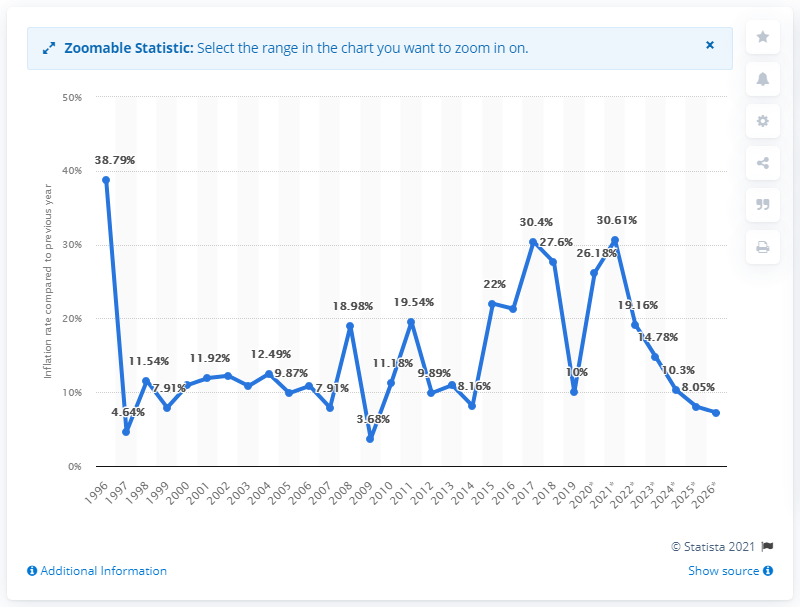Mention a couple of crucial points in this snapshot. In 2019, the inflation rate in Yemen was 10%. 